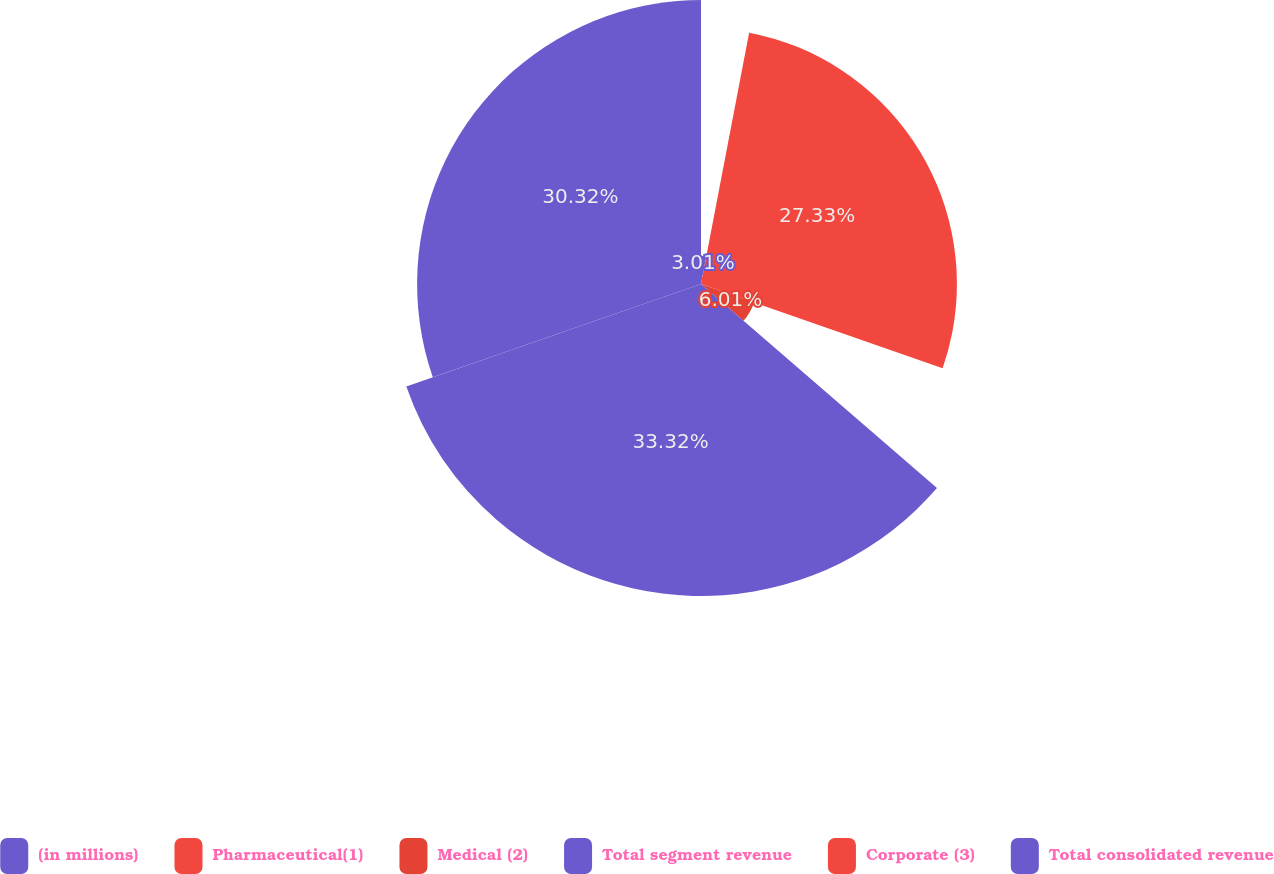Convert chart. <chart><loc_0><loc_0><loc_500><loc_500><pie_chart><fcel>(in millions)<fcel>Pharmaceutical(1)<fcel>Medical (2)<fcel>Total segment revenue<fcel>Corporate (3)<fcel>Total consolidated revenue<nl><fcel>3.01%<fcel>27.33%<fcel>6.01%<fcel>33.32%<fcel>0.01%<fcel>30.32%<nl></chart> 